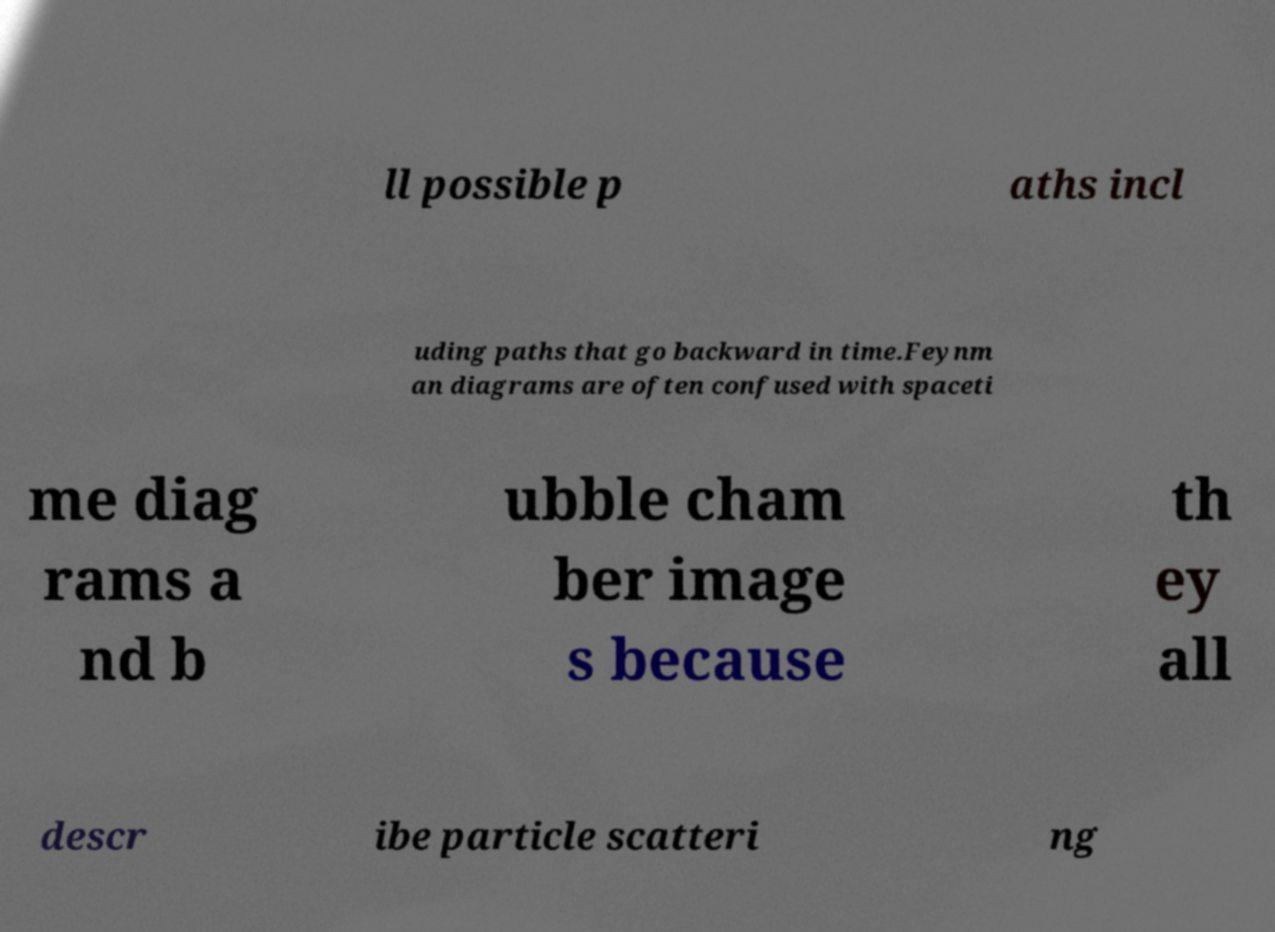I need the written content from this picture converted into text. Can you do that? ll possible p aths incl uding paths that go backward in time.Feynm an diagrams are often confused with spaceti me diag rams a nd b ubble cham ber image s because th ey all descr ibe particle scatteri ng 